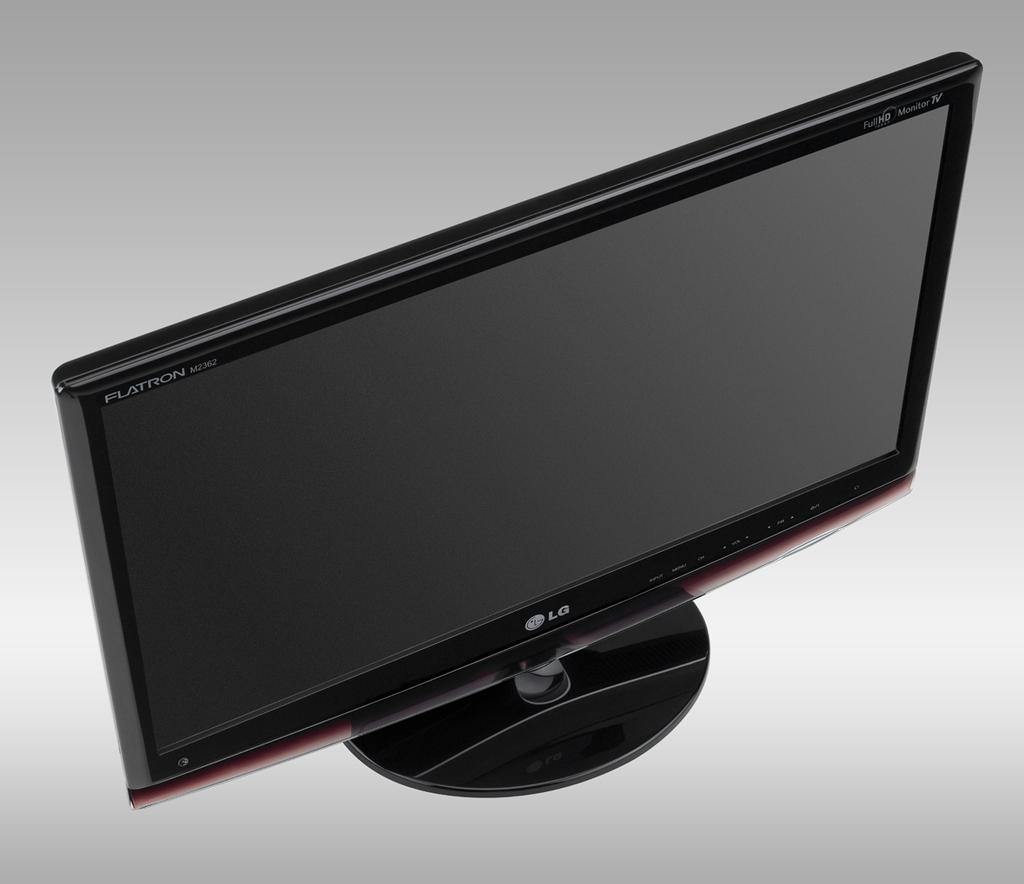<image>
Describe the image concisely. An LG black flatscreen tv is sitting on a surface. 